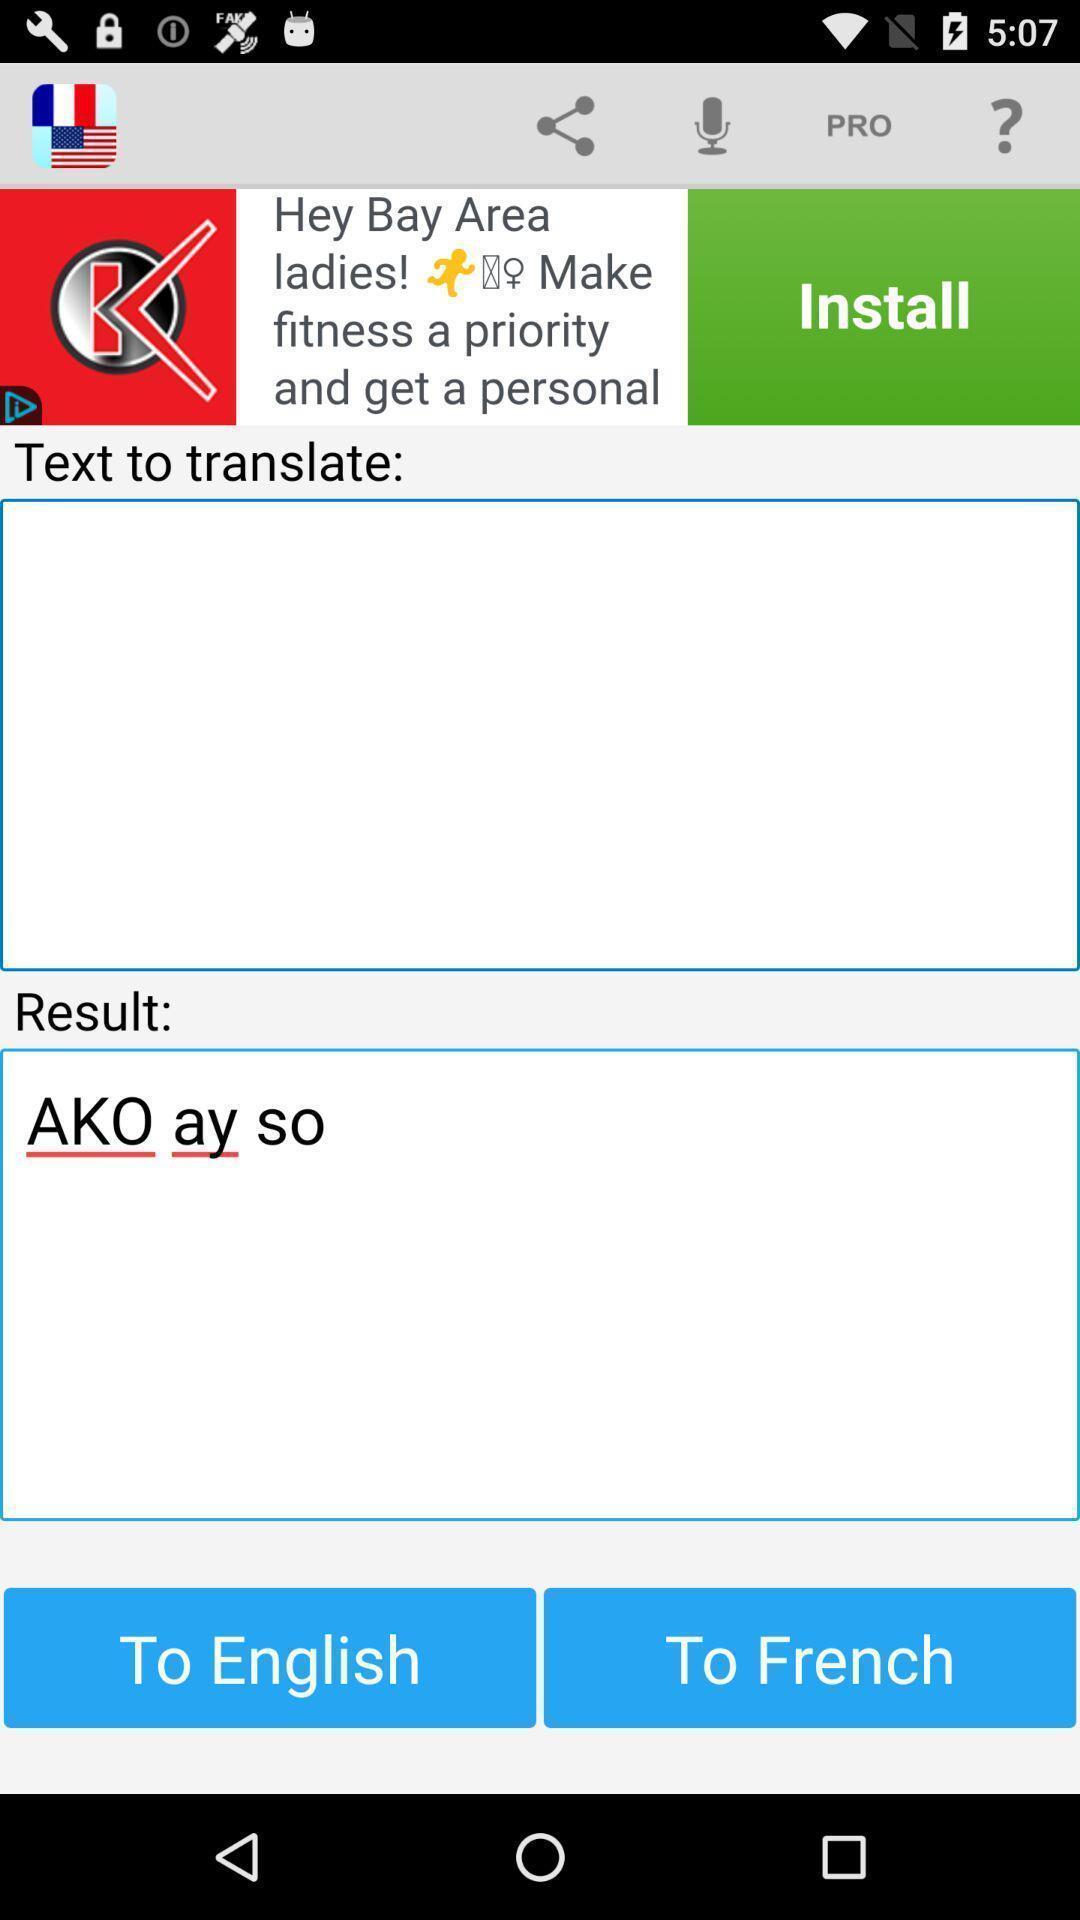Tell me about the visual elements in this screen capture. Translation page in a language translation application. 